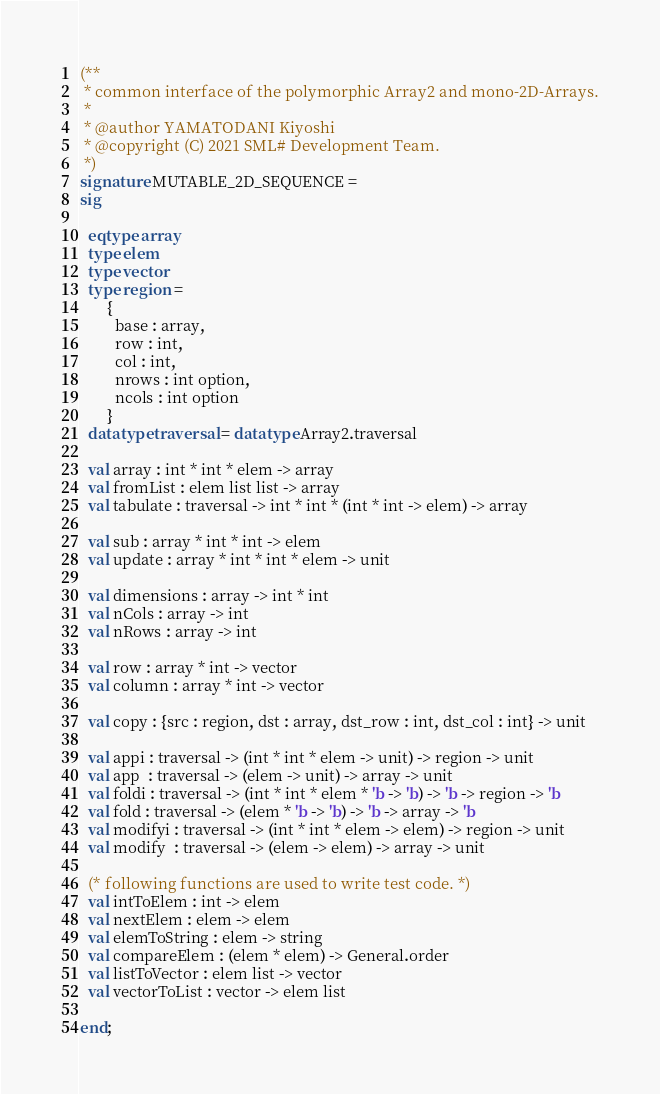Convert code to text. <code><loc_0><loc_0><loc_500><loc_500><_SML_>(**
 * common interface of the polymorphic Array2 and mono-2D-Arrays.
 *
 * @author YAMATODANI Kiyoshi
 * @copyright (C) 2021 SML# Development Team.
 *)
signature MUTABLE_2D_SEQUENCE =
sig

  eqtype array
  type elem
  type vector
  type region =
       {
         base : array,
         row : int,
         col : int,
         nrows : int option,
         ncols : int option
       }
  datatype traversal = datatype Array2.traversal

  val array : int * int * elem -> array
  val fromList : elem list list -> array
  val tabulate : traversal -> int * int * (int * int -> elem) -> array

  val sub : array * int * int -> elem
  val update : array * int * int * elem -> unit

  val dimensions : array -> int * int
  val nCols : array -> int
  val nRows : array -> int

  val row : array * int -> vector
  val column : array * int -> vector

  val copy : {src : region, dst : array, dst_row : int, dst_col : int} -> unit

  val appi : traversal -> (int * int * elem -> unit) -> region -> unit
  val app  : traversal -> (elem -> unit) -> array -> unit
  val foldi : traversal -> (int * int * elem * 'b -> 'b) -> 'b -> region -> 'b
  val fold : traversal -> (elem * 'b -> 'b) -> 'b -> array -> 'b
  val modifyi : traversal -> (int * int * elem -> elem) -> region -> unit
  val modify  : traversal -> (elem -> elem) -> array -> unit 

  (* following functions are used to write test code. *)
  val intToElem : int -> elem
  val nextElem : elem -> elem
  val elemToString : elem -> string
  val compareElem : (elem * elem) -> General.order
  val listToVector : elem list -> vector
  val vectorToList : vector -> elem list

end;
</code> 